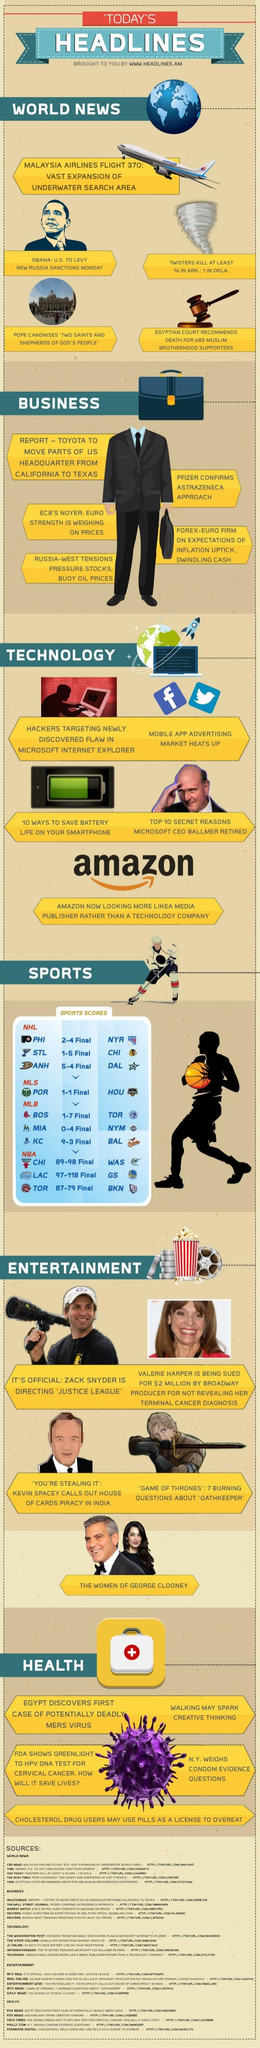Mention a couple of crucial points in this snapshot. The second news given under entertainment is about Valarie Harper. It is reported that a picture of Obama is featured under the category of world news. The infographic presents six different areas of news. 